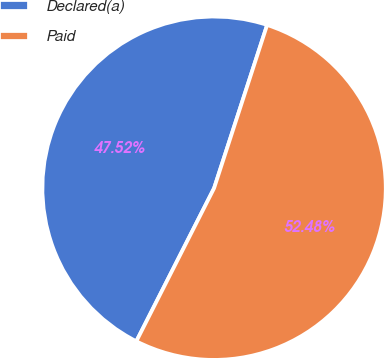Convert chart to OTSL. <chart><loc_0><loc_0><loc_500><loc_500><pie_chart><fcel>Declared(a)<fcel>Paid<nl><fcel>47.52%<fcel>52.48%<nl></chart> 